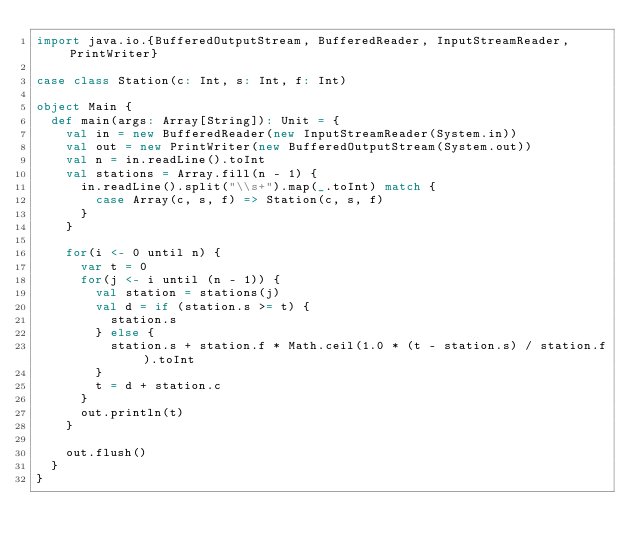<code> <loc_0><loc_0><loc_500><loc_500><_Scala_>import java.io.{BufferedOutputStream, BufferedReader, InputStreamReader, PrintWriter}

case class Station(c: Int, s: Int, f: Int)

object Main {
  def main(args: Array[String]): Unit = {
    val in = new BufferedReader(new InputStreamReader(System.in))
    val out = new PrintWriter(new BufferedOutputStream(System.out))
    val n = in.readLine().toInt
    val stations = Array.fill(n - 1) {
      in.readLine().split("\\s+").map(_.toInt) match {
        case Array(c, s, f) => Station(c, s, f)
      }
    }

    for(i <- 0 until n) {
      var t = 0
      for(j <- i until (n - 1)) {
        val station = stations(j)
        val d = if (station.s >= t) {
          station.s
        } else {
          station.s + station.f * Math.ceil(1.0 * (t - station.s) / station.f).toInt
        }
        t = d + station.c
      }
      out.println(t)
    }

    out.flush()
  }
}
</code> 